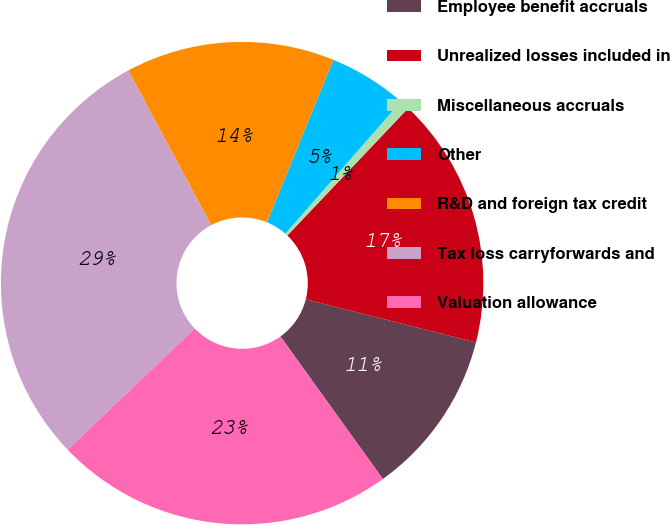Convert chart. <chart><loc_0><loc_0><loc_500><loc_500><pie_chart><fcel>Employee benefit accruals<fcel>Unrealized losses included in<fcel>Miscellaneous accruals<fcel>Other<fcel>R&D and foreign tax credit<fcel>Tax loss carryforwards and<fcel>Valuation allowance<nl><fcel>11.13%<fcel>16.87%<fcel>0.65%<fcel>5.26%<fcel>14.0%<fcel>29.31%<fcel>22.78%<nl></chart> 